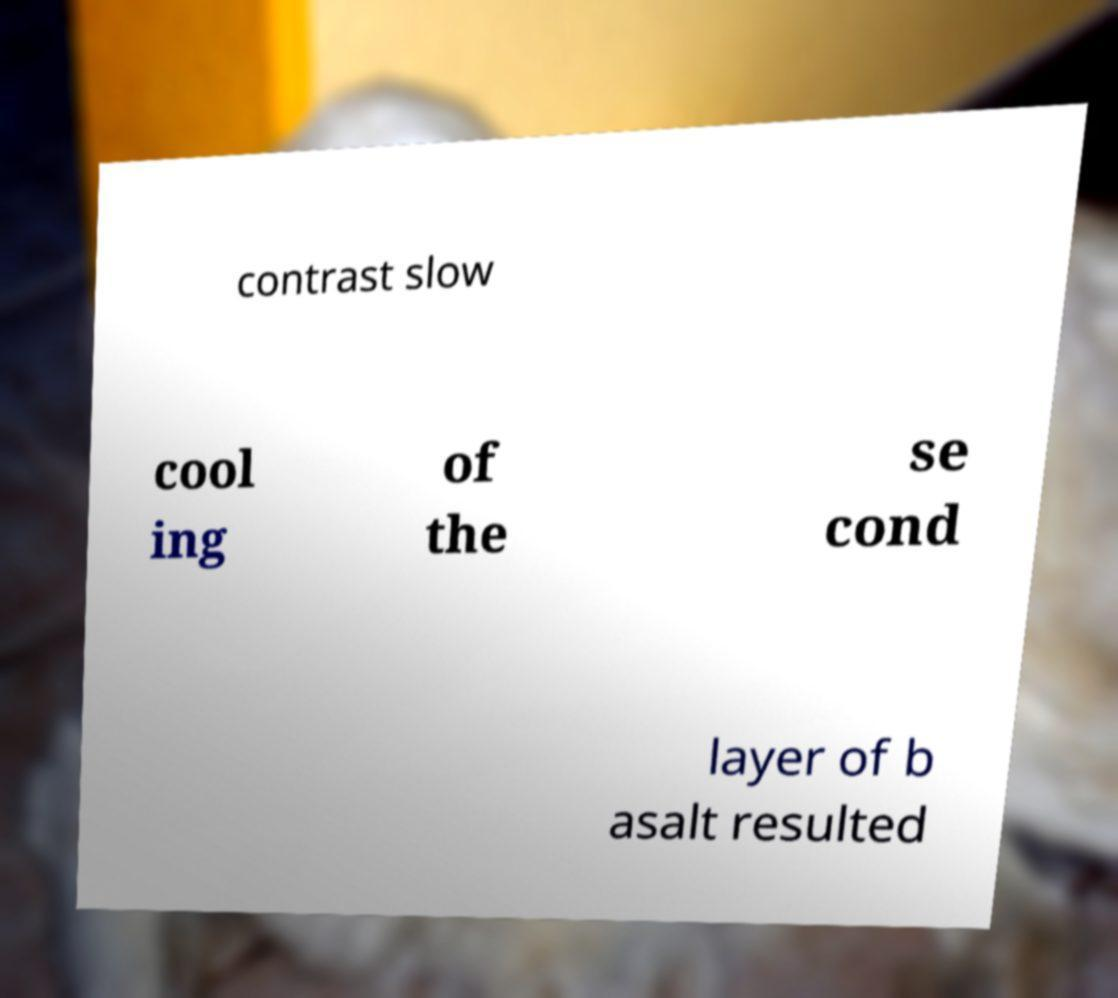I need the written content from this picture converted into text. Can you do that? contrast slow cool ing of the se cond layer of b asalt resulted 